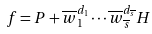<formula> <loc_0><loc_0><loc_500><loc_500>f = P + \overline { w } _ { 1 } ^ { d _ { 1 } } \cdots \overline { w } _ { \overline { s } } ^ { d _ { \overline { s } } } H</formula> 